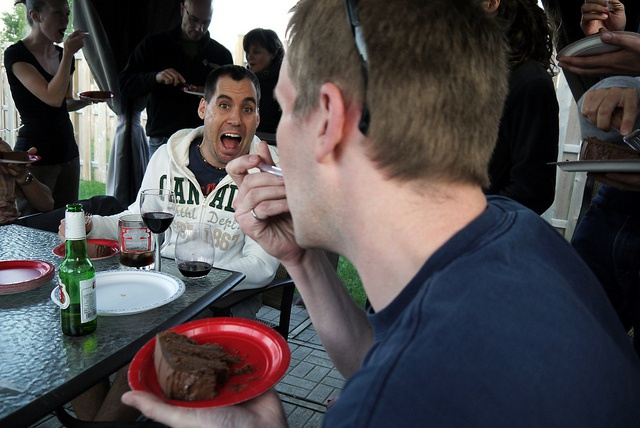Describe the objects in this image and their specific colors. I can see people in white, black, navy, darkgray, and tan tones, dining table in white, black, gray, and lightblue tones, people in white, lightgray, darkgray, black, and gray tones, people in white, black, and darkgray tones, and people in white, black, gray, and maroon tones in this image. 